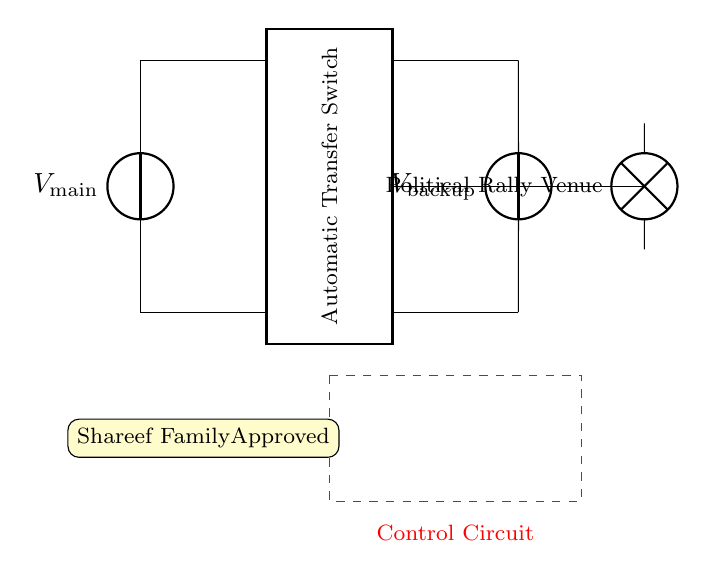What is the main power supply voltage? The circuit shows a voltage source labeled as \(V_{main}\), which indicates it is the main power supply. The specific voltage value is not given but is represented by the symbol.
Answer: V main What is the role of the Automatic Transfer Switch? The Automatic Transfer Switch, depicted by the rectangle, is responsible for switching the power source between the main supply and the backup generator as needed. This ensures continuous power supply during outages.
Answer: Power switching Which voltage source represents the backup generator? The voltage source labeled as \(V_{backup}\) represents the backup generator, indicated by its specific label and connection in the circuit diagram.
Answer: V backup What is the load in this circuit? The load in this diagram is marked as "Political Rally Venue", indicating the device or system that is being powered by the circuit.
Answer: Political Rally Venue How does the control circuit function in this setup? The control circuit, shown by the dashed red lines, connects to both the Automatic Transfer Switch and the backup generator. It monitors and controls the switching mechanism, ensuring that power is redirected during any supply interruptions.
Answer: Switching mechanism What does the yellow stamp represent in this circuit? The yellow stamp labeled "Shareef Family Approved" indicates that the circuit design has received endorsement or approval from the Shareef family, which is a notable context in this situation.
Answer: Approval 